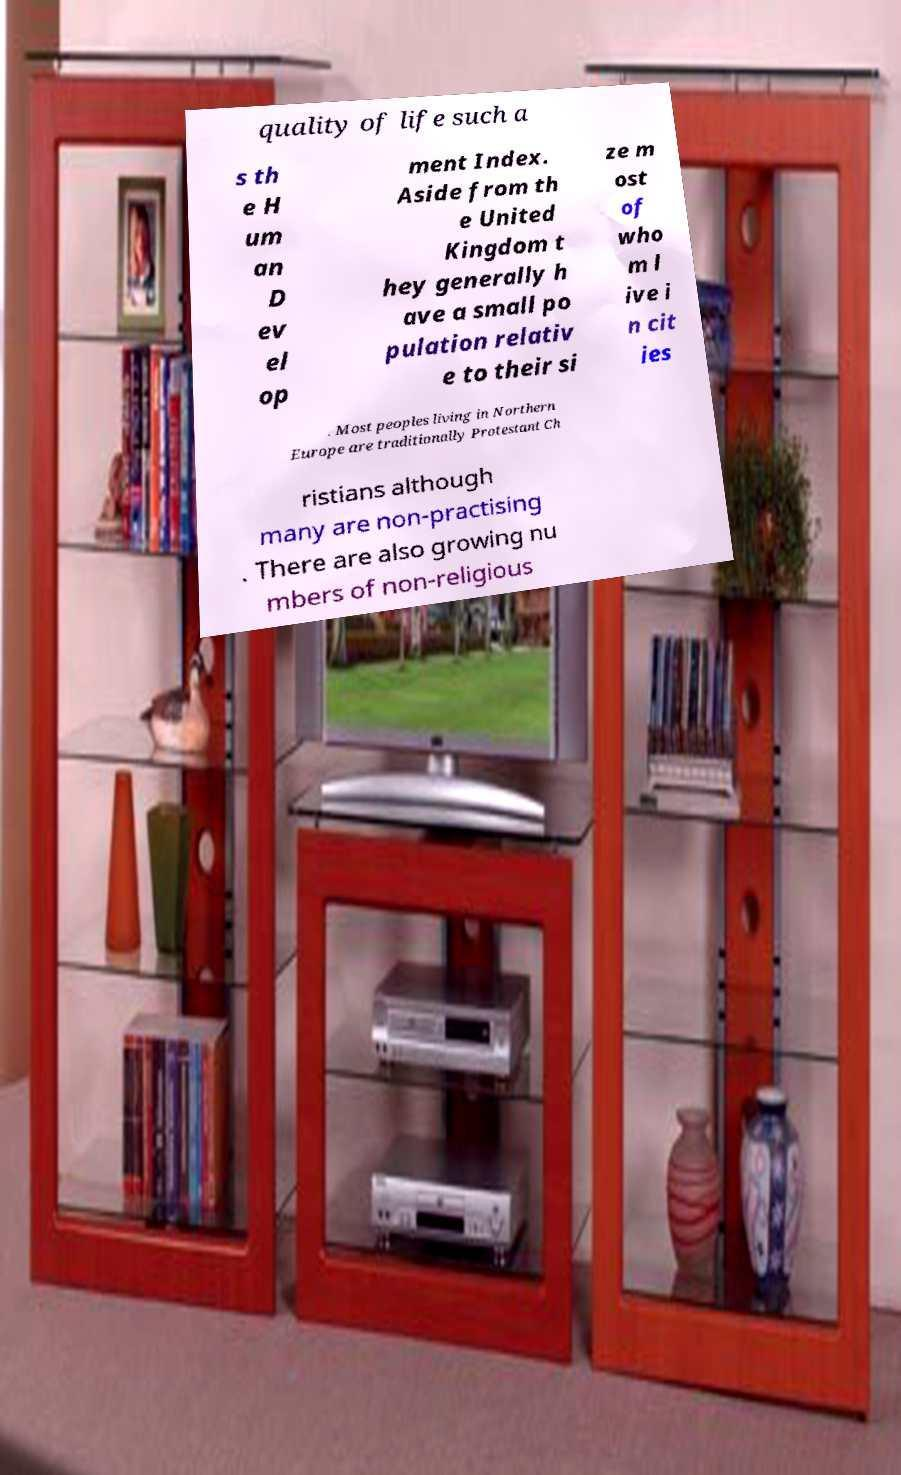What messages or text are displayed in this image? I need them in a readable, typed format. quality of life such a s th e H um an D ev el op ment Index. Aside from th e United Kingdom t hey generally h ave a small po pulation relativ e to their si ze m ost of who m l ive i n cit ies . Most peoples living in Northern Europe are traditionally Protestant Ch ristians although many are non-practising . There are also growing nu mbers of non-religious 